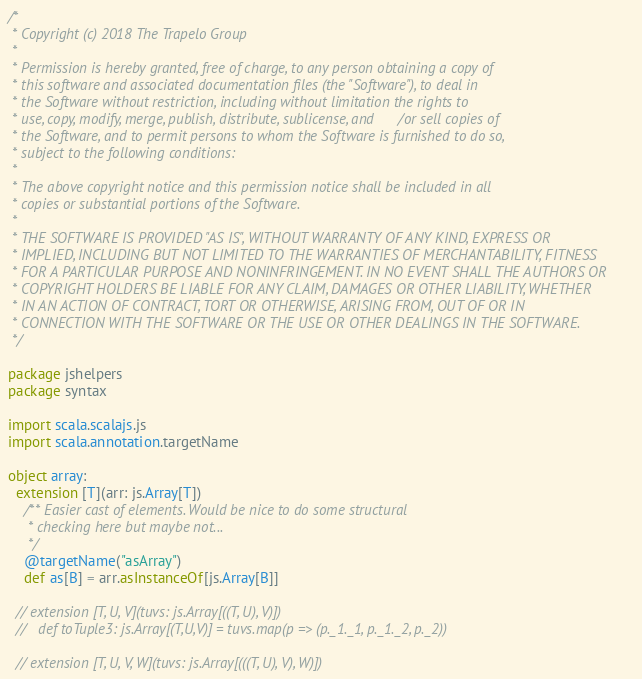<code> <loc_0><loc_0><loc_500><loc_500><_Scala_>/*
 * Copyright (c) 2018 The Trapelo Group
 *
 * Permission is hereby granted, free of charge, to any person obtaining a copy of
 * this software and associated documentation files (the "Software"), to deal in
 * the Software without restriction, including without limitation the rights to
 * use, copy, modify, merge, publish, distribute, sublicense, and/or sell copies of
 * the Software, and to permit persons to whom the Software is furnished to do so,
 * subject to the following conditions:
 *
 * The above copyright notice and this permission notice shall be included in all
 * copies or substantial portions of the Software.
 *
 * THE SOFTWARE IS PROVIDED "AS IS", WITHOUT WARRANTY OF ANY KIND, EXPRESS OR
 * IMPLIED, INCLUDING BUT NOT LIMITED TO THE WARRANTIES OF MERCHANTABILITY, FITNESS
 * FOR A PARTICULAR PURPOSE AND NONINFRINGEMENT. IN NO EVENT SHALL THE AUTHORS OR
 * COPYRIGHT HOLDERS BE LIABLE FOR ANY CLAIM, DAMAGES OR OTHER LIABILITY, WHETHER
 * IN AN ACTION OF CONTRACT, TORT OR OTHERWISE, ARISING FROM, OUT OF OR IN
 * CONNECTION WITH THE SOFTWARE OR THE USE OR OTHER DEALINGS IN THE SOFTWARE.
 */

package jshelpers
package syntax

import scala.scalajs.js
import scala.annotation.targetName

object array:
  extension [T](arr: js.Array[T])
    /** Easier cast of elements. Would be nice to do some structural
     * checking here but maybe not...
     */
    @targetName("asArray")
    def as[B] = arr.asInstanceOf[js.Array[B]]

  // extension [T, U, V](tuvs: js.Array[((T, U), V)])
  //   def toTuple3: js.Array[(T,U,V)] = tuvs.map(p => (p._1._1, p._1._2, p._2))

  // extension [T, U, V, W](tuvs: js.Array[(((T, U), V), W)])</code> 